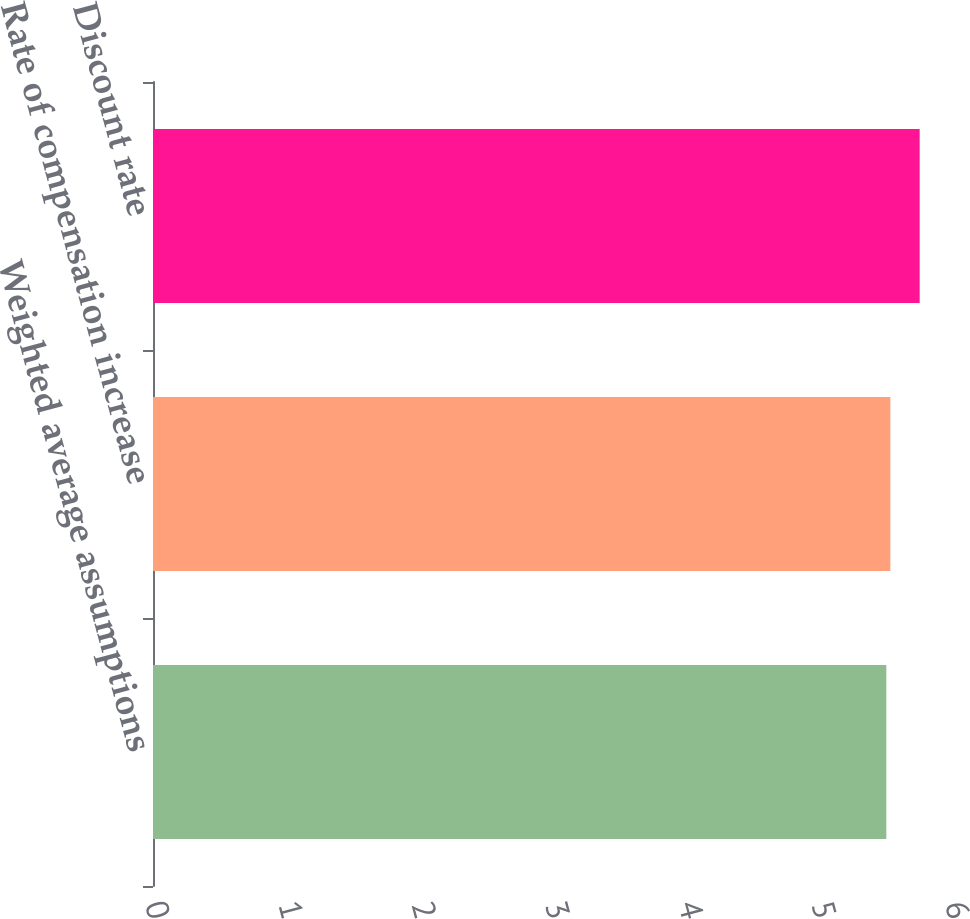Convert chart. <chart><loc_0><loc_0><loc_500><loc_500><bar_chart><fcel>Weighted average assumptions<fcel>Rate of compensation increase<fcel>Discount rate<nl><fcel>5.5<fcel>5.53<fcel>5.75<nl></chart> 